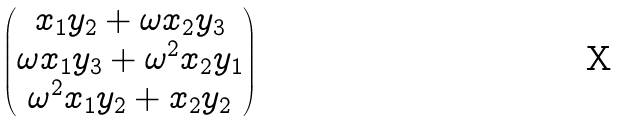<formula> <loc_0><loc_0><loc_500><loc_500>\begin{pmatrix} x _ { 1 } y _ { 2 } + \omega x _ { 2 } y _ { 3 } \\ \omega x _ { 1 } y _ { 3 } + \omega ^ { 2 } x _ { 2 } y _ { 1 } \\ \omega ^ { 2 } x _ { 1 } y _ { 2 } + x _ { 2 } y _ { 2 } \end{pmatrix}</formula> 